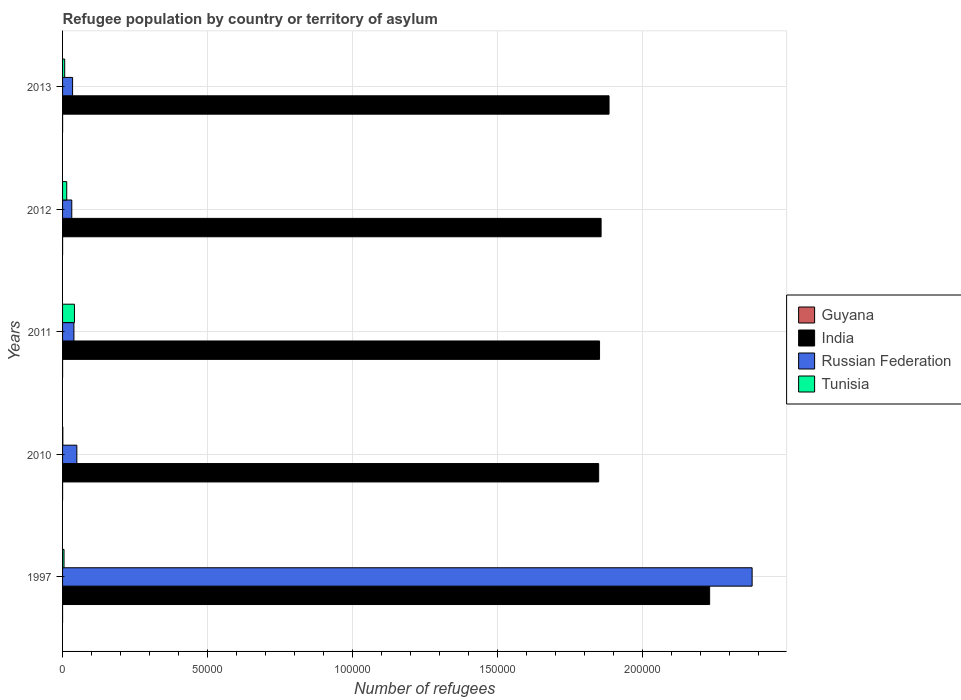How many groups of bars are there?
Your answer should be very brief. 5. Are the number of bars per tick equal to the number of legend labels?
Your answer should be compact. Yes. Are the number of bars on each tick of the Y-axis equal?
Provide a short and direct response. Yes. How many bars are there on the 2nd tick from the bottom?
Your response must be concise. 4. What is the number of refugees in Russian Federation in 2011?
Keep it short and to the point. 3914. Across all years, what is the maximum number of refugees in India?
Ensure brevity in your answer.  2.23e+05. In which year was the number of refugees in Tunisia minimum?
Offer a very short reply. 2010. What is the total number of refugees in Tunisia in the graph?
Offer a very short reply. 6857. What is the difference between the number of refugees in Tunisia in 1997 and that in 2011?
Your answer should be compact. -3591. What is the difference between the number of refugees in Russian Federation in 2013 and the number of refugees in Tunisia in 2012?
Provide a succinct answer. 2023. What is the average number of refugees in Tunisia per year?
Offer a terse response. 1371.4. In the year 2013, what is the difference between the number of refugees in Guyana and number of refugees in Russian Federation?
Give a very brief answer. -3447. In how many years, is the number of refugees in Russian Federation greater than 20000 ?
Your answer should be very brief. 1. What is the ratio of the number of refugees in Tunisia in 2010 to that in 2012?
Make the answer very short. 0.06. Is the number of refugees in Guyana in 2011 less than that in 2013?
Your answer should be compact. Yes. Is the difference between the number of refugees in Guyana in 1997 and 2013 greater than the difference between the number of refugees in Russian Federation in 1997 and 2013?
Make the answer very short. No. What is the difference between the highest and the second highest number of refugees in Tunisia?
Your answer should be very brief. 2662. What is the difference between the highest and the lowest number of refugees in India?
Offer a terse response. 3.83e+04. Is it the case that in every year, the sum of the number of refugees in Guyana and number of refugees in Tunisia is greater than the sum of number of refugees in India and number of refugees in Russian Federation?
Ensure brevity in your answer.  No. What does the 2nd bar from the top in 2011 represents?
Offer a terse response. Russian Federation. What does the 1st bar from the bottom in 1997 represents?
Provide a succinct answer. Guyana. How many years are there in the graph?
Make the answer very short. 5. What is the difference between two consecutive major ticks on the X-axis?
Offer a terse response. 5.00e+04. Are the values on the major ticks of X-axis written in scientific E-notation?
Offer a very short reply. No. How many legend labels are there?
Make the answer very short. 4. How are the legend labels stacked?
Your answer should be very brief. Vertical. What is the title of the graph?
Offer a very short reply. Refugee population by country or territory of asylum. What is the label or title of the X-axis?
Provide a short and direct response. Number of refugees. What is the Number of refugees in India in 1997?
Offer a terse response. 2.23e+05. What is the Number of refugees in Russian Federation in 1997?
Make the answer very short. 2.38e+05. What is the Number of refugees of Tunisia in 1997?
Provide a short and direct response. 506. What is the Number of refugees in Guyana in 2010?
Keep it short and to the point. 7. What is the Number of refugees in India in 2010?
Provide a succinct answer. 1.85e+05. What is the Number of refugees in Russian Federation in 2010?
Offer a very short reply. 4922. What is the Number of refugees of Tunisia in 2010?
Ensure brevity in your answer.  89. What is the Number of refugees in India in 2011?
Provide a short and direct response. 1.85e+05. What is the Number of refugees of Russian Federation in 2011?
Give a very brief answer. 3914. What is the Number of refugees in Tunisia in 2011?
Keep it short and to the point. 4097. What is the Number of refugees in India in 2012?
Give a very brief answer. 1.86e+05. What is the Number of refugees of Russian Federation in 2012?
Give a very brief answer. 3178. What is the Number of refugees in Tunisia in 2012?
Your response must be concise. 1435. What is the Number of refugees of India in 2013?
Offer a terse response. 1.88e+05. What is the Number of refugees in Russian Federation in 2013?
Ensure brevity in your answer.  3458. What is the Number of refugees of Tunisia in 2013?
Give a very brief answer. 730. Across all years, what is the maximum Number of refugees of Guyana?
Your answer should be compact. 11. Across all years, what is the maximum Number of refugees of India?
Offer a terse response. 2.23e+05. Across all years, what is the maximum Number of refugees of Russian Federation?
Provide a short and direct response. 2.38e+05. Across all years, what is the maximum Number of refugees of Tunisia?
Offer a very short reply. 4097. Across all years, what is the minimum Number of refugees of Guyana?
Give a very brief answer. 1. Across all years, what is the minimum Number of refugees of India?
Offer a terse response. 1.85e+05. Across all years, what is the minimum Number of refugees in Russian Federation?
Make the answer very short. 3178. Across all years, what is the minimum Number of refugees in Tunisia?
Provide a short and direct response. 89. What is the total Number of refugees of Guyana in the graph?
Offer a very short reply. 33. What is the total Number of refugees in India in the graph?
Keep it short and to the point. 9.67e+05. What is the total Number of refugees in Russian Federation in the graph?
Your answer should be very brief. 2.53e+05. What is the total Number of refugees in Tunisia in the graph?
Keep it short and to the point. 6857. What is the difference between the Number of refugees of India in 1997 and that in 2010?
Your answer should be compact. 3.83e+04. What is the difference between the Number of refugees of Russian Federation in 1997 and that in 2010?
Ensure brevity in your answer.  2.33e+05. What is the difference between the Number of refugees of Tunisia in 1997 and that in 2010?
Your answer should be compact. 417. What is the difference between the Number of refugees of India in 1997 and that in 2011?
Your answer should be compact. 3.80e+04. What is the difference between the Number of refugees in Russian Federation in 1997 and that in 2011?
Your answer should be compact. 2.34e+05. What is the difference between the Number of refugees of Tunisia in 1997 and that in 2011?
Provide a short and direct response. -3591. What is the difference between the Number of refugees of Guyana in 1997 and that in 2012?
Your answer should be very brief. -6. What is the difference between the Number of refugees of India in 1997 and that in 2012?
Your answer should be compact. 3.74e+04. What is the difference between the Number of refugees in Russian Federation in 1997 and that in 2012?
Your answer should be very brief. 2.35e+05. What is the difference between the Number of refugees in Tunisia in 1997 and that in 2012?
Provide a succinct answer. -929. What is the difference between the Number of refugees in Guyana in 1997 and that in 2013?
Offer a very short reply. -10. What is the difference between the Number of refugees of India in 1997 and that in 2013?
Your answer should be compact. 3.47e+04. What is the difference between the Number of refugees in Russian Federation in 1997 and that in 2013?
Your answer should be compact. 2.34e+05. What is the difference between the Number of refugees of Tunisia in 1997 and that in 2013?
Ensure brevity in your answer.  -224. What is the difference between the Number of refugees in India in 2010 and that in 2011?
Give a very brief answer. -297. What is the difference between the Number of refugees in Russian Federation in 2010 and that in 2011?
Ensure brevity in your answer.  1008. What is the difference between the Number of refugees in Tunisia in 2010 and that in 2011?
Offer a terse response. -4008. What is the difference between the Number of refugees in India in 2010 and that in 2012?
Give a very brief answer. -835. What is the difference between the Number of refugees in Russian Federation in 2010 and that in 2012?
Provide a short and direct response. 1744. What is the difference between the Number of refugees of Tunisia in 2010 and that in 2012?
Ensure brevity in your answer.  -1346. What is the difference between the Number of refugees in Guyana in 2010 and that in 2013?
Make the answer very short. -4. What is the difference between the Number of refugees of India in 2010 and that in 2013?
Offer a very short reply. -3574. What is the difference between the Number of refugees of Russian Federation in 2010 and that in 2013?
Keep it short and to the point. 1464. What is the difference between the Number of refugees of Tunisia in 2010 and that in 2013?
Provide a succinct answer. -641. What is the difference between the Number of refugees of Guyana in 2011 and that in 2012?
Provide a short and direct response. 0. What is the difference between the Number of refugees in India in 2011 and that in 2012?
Make the answer very short. -538. What is the difference between the Number of refugees of Russian Federation in 2011 and that in 2012?
Keep it short and to the point. 736. What is the difference between the Number of refugees in Tunisia in 2011 and that in 2012?
Keep it short and to the point. 2662. What is the difference between the Number of refugees of Guyana in 2011 and that in 2013?
Make the answer very short. -4. What is the difference between the Number of refugees of India in 2011 and that in 2013?
Ensure brevity in your answer.  -3277. What is the difference between the Number of refugees in Russian Federation in 2011 and that in 2013?
Provide a short and direct response. 456. What is the difference between the Number of refugees in Tunisia in 2011 and that in 2013?
Your answer should be very brief. 3367. What is the difference between the Number of refugees in India in 2012 and that in 2013?
Offer a very short reply. -2739. What is the difference between the Number of refugees of Russian Federation in 2012 and that in 2013?
Your answer should be very brief. -280. What is the difference between the Number of refugees in Tunisia in 2012 and that in 2013?
Ensure brevity in your answer.  705. What is the difference between the Number of refugees of Guyana in 1997 and the Number of refugees of India in 2010?
Keep it short and to the point. -1.85e+05. What is the difference between the Number of refugees of Guyana in 1997 and the Number of refugees of Russian Federation in 2010?
Keep it short and to the point. -4921. What is the difference between the Number of refugees of Guyana in 1997 and the Number of refugees of Tunisia in 2010?
Provide a short and direct response. -88. What is the difference between the Number of refugees in India in 1997 and the Number of refugees in Russian Federation in 2010?
Provide a succinct answer. 2.18e+05. What is the difference between the Number of refugees in India in 1997 and the Number of refugees in Tunisia in 2010?
Your answer should be very brief. 2.23e+05. What is the difference between the Number of refugees in Russian Federation in 1997 and the Number of refugees in Tunisia in 2010?
Your answer should be compact. 2.38e+05. What is the difference between the Number of refugees in Guyana in 1997 and the Number of refugees in India in 2011?
Give a very brief answer. -1.85e+05. What is the difference between the Number of refugees in Guyana in 1997 and the Number of refugees in Russian Federation in 2011?
Your answer should be compact. -3913. What is the difference between the Number of refugees of Guyana in 1997 and the Number of refugees of Tunisia in 2011?
Your answer should be very brief. -4096. What is the difference between the Number of refugees of India in 1997 and the Number of refugees of Russian Federation in 2011?
Ensure brevity in your answer.  2.19e+05. What is the difference between the Number of refugees in India in 1997 and the Number of refugees in Tunisia in 2011?
Offer a terse response. 2.19e+05. What is the difference between the Number of refugees in Russian Federation in 1997 and the Number of refugees in Tunisia in 2011?
Your answer should be very brief. 2.34e+05. What is the difference between the Number of refugees of Guyana in 1997 and the Number of refugees of India in 2012?
Your answer should be compact. -1.86e+05. What is the difference between the Number of refugees in Guyana in 1997 and the Number of refugees in Russian Federation in 2012?
Provide a short and direct response. -3177. What is the difference between the Number of refugees of Guyana in 1997 and the Number of refugees of Tunisia in 2012?
Offer a terse response. -1434. What is the difference between the Number of refugees in India in 1997 and the Number of refugees in Russian Federation in 2012?
Ensure brevity in your answer.  2.20e+05. What is the difference between the Number of refugees of India in 1997 and the Number of refugees of Tunisia in 2012?
Offer a terse response. 2.22e+05. What is the difference between the Number of refugees in Russian Federation in 1997 and the Number of refugees in Tunisia in 2012?
Ensure brevity in your answer.  2.36e+05. What is the difference between the Number of refugees of Guyana in 1997 and the Number of refugees of India in 2013?
Ensure brevity in your answer.  -1.88e+05. What is the difference between the Number of refugees of Guyana in 1997 and the Number of refugees of Russian Federation in 2013?
Offer a terse response. -3457. What is the difference between the Number of refugees of Guyana in 1997 and the Number of refugees of Tunisia in 2013?
Your answer should be compact. -729. What is the difference between the Number of refugees in India in 1997 and the Number of refugees in Russian Federation in 2013?
Ensure brevity in your answer.  2.20e+05. What is the difference between the Number of refugees of India in 1997 and the Number of refugees of Tunisia in 2013?
Give a very brief answer. 2.22e+05. What is the difference between the Number of refugees of Russian Federation in 1997 and the Number of refugees of Tunisia in 2013?
Give a very brief answer. 2.37e+05. What is the difference between the Number of refugees in Guyana in 2010 and the Number of refugees in India in 2011?
Make the answer very short. -1.85e+05. What is the difference between the Number of refugees in Guyana in 2010 and the Number of refugees in Russian Federation in 2011?
Provide a short and direct response. -3907. What is the difference between the Number of refugees of Guyana in 2010 and the Number of refugees of Tunisia in 2011?
Provide a succinct answer. -4090. What is the difference between the Number of refugees of India in 2010 and the Number of refugees of Russian Federation in 2011?
Your answer should be very brief. 1.81e+05. What is the difference between the Number of refugees in India in 2010 and the Number of refugees in Tunisia in 2011?
Provide a succinct answer. 1.81e+05. What is the difference between the Number of refugees of Russian Federation in 2010 and the Number of refugees of Tunisia in 2011?
Give a very brief answer. 825. What is the difference between the Number of refugees in Guyana in 2010 and the Number of refugees in India in 2012?
Keep it short and to the point. -1.86e+05. What is the difference between the Number of refugees in Guyana in 2010 and the Number of refugees in Russian Federation in 2012?
Give a very brief answer. -3171. What is the difference between the Number of refugees of Guyana in 2010 and the Number of refugees of Tunisia in 2012?
Your answer should be compact. -1428. What is the difference between the Number of refugees of India in 2010 and the Number of refugees of Russian Federation in 2012?
Ensure brevity in your answer.  1.82e+05. What is the difference between the Number of refugees in India in 2010 and the Number of refugees in Tunisia in 2012?
Provide a succinct answer. 1.83e+05. What is the difference between the Number of refugees of Russian Federation in 2010 and the Number of refugees of Tunisia in 2012?
Offer a terse response. 3487. What is the difference between the Number of refugees of Guyana in 2010 and the Number of refugees of India in 2013?
Offer a very short reply. -1.88e+05. What is the difference between the Number of refugees of Guyana in 2010 and the Number of refugees of Russian Federation in 2013?
Make the answer very short. -3451. What is the difference between the Number of refugees in Guyana in 2010 and the Number of refugees in Tunisia in 2013?
Offer a terse response. -723. What is the difference between the Number of refugees in India in 2010 and the Number of refugees in Russian Federation in 2013?
Give a very brief answer. 1.81e+05. What is the difference between the Number of refugees in India in 2010 and the Number of refugees in Tunisia in 2013?
Make the answer very short. 1.84e+05. What is the difference between the Number of refugees of Russian Federation in 2010 and the Number of refugees of Tunisia in 2013?
Keep it short and to the point. 4192. What is the difference between the Number of refugees of Guyana in 2011 and the Number of refugees of India in 2012?
Provide a short and direct response. -1.86e+05. What is the difference between the Number of refugees of Guyana in 2011 and the Number of refugees of Russian Federation in 2012?
Offer a very short reply. -3171. What is the difference between the Number of refugees of Guyana in 2011 and the Number of refugees of Tunisia in 2012?
Offer a terse response. -1428. What is the difference between the Number of refugees of India in 2011 and the Number of refugees of Russian Federation in 2012?
Provide a short and direct response. 1.82e+05. What is the difference between the Number of refugees of India in 2011 and the Number of refugees of Tunisia in 2012?
Your answer should be very brief. 1.84e+05. What is the difference between the Number of refugees of Russian Federation in 2011 and the Number of refugees of Tunisia in 2012?
Provide a succinct answer. 2479. What is the difference between the Number of refugees in Guyana in 2011 and the Number of refugees in India in 2013?
Ensure brevity in your answer.  -1.88e+05. What is the difference between the Number of refugees of Guyana in 2011 and the Number of refugees of Russian Federation in 2013?
Give a very brief answer. -3451. What is the difference between the Number of refugees in Guyana in 2011 and the Number of refugees in Tunisia in 2013?
Your response must be concise. -723. What is the difference between the Number of refugees in India in 2011 and the Number of refugees in Russian Federation in 2013?
Ensure brevity in your answer.  1.82e+05. What is the difference between the Number of refugees of India in 2011 and the Number of refugees of Tunisia in 2013?
Offer a terse response. 1.84e+05. What is the difference between the Number of refugees of Russian Federation in 2011 and the Number of refugees of Tunisia in 2013?
Keep it short and to the point. 3184. What is the difference between the Number of refugees in Guyana in 2012 and the Number of refugees in India in 2013?
Your answer should be compact. -1.88e+05. What is the difference between the Number of refugees of Guyana in 2012 and the Number of refugees of Russian Federation in 2013?
Your answer should be compact. -3451. What is the difference between the Number of refugees in Guyana in 2012 and the Number of refugees in Tunisia in 2013?
Your response must be concise. -723. What is the difference between the Number of refugees of India in 2012 and the Number of refugees of Russian Federation in 2013?
Your answer should be compact. 1.82e+05. What is the difference between the Number of refugees of India in 2012 and the Number of refugees of Tunisia in 2013?
Offer a very short reply. 1.85e+05. What is the difference between the Number of refugees in Russian Federation in 2012 and the Number of refugees in Tunisia in 2013?
Your answer should be compact. 2448. What is the average Number of refugees of India per year?
Your answer should be compact. 1.93e+05. What is the average Number of refugees in Russian Federation per year?
Provide a succinct answer. 5.06e+04. What is the average Number of refugees in Tunisia per year?
Keep it short and to the point. 1371.4. In the year 1997, what is the difference between the Number of refugees of Guyana and Number of refugees of India?
Your response must be concise. -2.23e+05. In the year 1997, what is the difference between the Number of refugees of Guyana and Number of refugees of Russian Federation?
Your response must be concise. -2.38e+05. In the year 1997, what is the difference between the Number of refugees in Guyana and Number of refugees in Tunisia?
Your answer should be compact. -505. In the year 1997, what is the difference between the Number of refugees in India and Number of refugees in Russian Federation?
Ensure brevity in your answer.  -1.46e+04. In the year 1997, what is the difference between the Number of refugees in India and Number of refugees in Tunisia?
Your response must be concise. 2.23e+05. In the year 1997, what is the difference between the Number of refugees of Russian Federation and Number of refugees of Tunisia?
Provide a short and direct response. 2.37e+05. In the year 2010, what is the difference between the Number of refugees of Guyana and Number of refugees of India?
Make the answer very short. -1.85e+05. In the year 2010, what is the difference between the Number of refugees of Guyana and Number of refugees of Russian Federation?
Provide a short and direct response. -4915. In the year 2010, what is the difference between the Number of refugees in Guyana and Number of refugees in Tunisia?
Keep it short and to the point. -82. In the year 2010, what is the difference between the Number of refugees in India and Number of refugees in Russian Federation?
Ensure brevity in your answer.  1.80e+05. In the year 2010, what is the difference between the Number of refugees of India and Number of refugees of Tunisia?
Keep it short and to the point. 1.85e+05. In the year 2010, what is the difference between the Number of refugees of Russian Federation and Number of refugees of Tunisia?
Offer a terse response. 4833. In the year 2011, what is the difference between the Number of refugees of Guyana and Number of refugees of India?
Give a very brief answer. -1.85e+05. In the year 2011, what is the difference between the Number of refugees in Guyana and Number of refugees in Russian Federation?
Keep it short and to the point. -3907. In the year 2011, what is the difference between the Number of refugees in Guyana and Number of refugees in Tunisia?
Provide a short and direct response. -4090. In the year 2011, what is the difference between the Number of refugees in India and Number of refugees in Russian Federation?
Ensure brevity in your answer.  1.81e+05. In the year 2011, what is the difference between the Number of refugees in India and Number of refugees in Tunisia?
Give a very brief answer. 1.81e+05. In the year 2011, what is the difference between the Number of refugees in Russian Federation and Number of refugees in Tunisia?
Your answer should be very brief. -183. In the year 2012, what is the difference between the Number of refugees of Guyana and Number of refugees of India?
Keep it short and to the point. -1.86e+05. In the year 2012, what is the difference between the Number of refugees of Guyana and Number of refugees of Russian Federation?
Offer a very short reply. -3171. In the year 2012, what is the difference between the Number of refugees in Guyana and Number of refugees in Tunisia?
Your answer should be very brief. -1428. In the year 2012, what is the difference between the Number of refugees in India and Number of refugees in Russian Federation?
Your answer should be compact. 1.82e+05. In the year 2012, what is the difference between the Number of refugees of India and Number of refugees of Tunisia?
Keep it short and to the point. 1.84e+05. In the year 2012, what is the difference between the Number of refugees in Russian Federation and Number of refugees in Tunisia?
Provide a short and direct response. 1743. In the year 2013, what is the difference between the Number of refugees of Guyana and Number of refugees of India?
Your answer should be compact. -1.88e+05. In the year 2013, what is the difference between the Number of refugees of Guyana and Number of refugees of Russian Federation?
Your answer should be compact. -3447. In the year 2013, what is the difference between the Number of refugees in Guyana and Number of refugees in Tunisia?
Make the answer very short. -719. In the year 2013, what is the difference between the Number of refugees in India and Number of refugees in Russian Federation?
Make the answer very short. 1.85e+05. In the year 2013, what is the difference between the Number of refugees of India and Number of refugees of Tunisia?
Offer a terse response. 1.88e+05. In the year 2013, what is the difference between the Number of refugees of Russian Federation and Number of refugees of Tunisia?
Offer a terse response. 2728. What is the ratio of the Number of refugees of Guyana in 1997 to that in 2010?
Your response must be concise. 0.14. What is the ratio of the Number of refugees in India in 1997 to that in 2010?
Your answer should be very brief. 1.21. What is the ratio of the Number of refugees in Russian Federation in 1997 to that in 2010?
Offer a very short reply. 48.3. What is the ratio of the Number of refugees of Tunisia in 1997 to that in 2010?
Your answer should be compact. 5.69. What is the ratio of the Number of refugees in Guyana in 1997 to that in 2011?
Your response must be concise. 0.14. What is the ratio of the Number of refugees in India in 1997 to that in 2011?
Offer a very short reply. 1.21. What is the ratio of the Number of refugees in Russian Federation in 1997 to that in 2011?
Offer a very short reply. 60.74. What is the ratio of the Number of refugees of Tunisia in 1997 to that in 2011?
Provide a succinct answer. 0.12. What is the ratio of the Number of refugees in Guyana in 1997 to that in 2012?
Offer a very short reply. 0.14. What is the ratio of the Number of refugees of India in 1997 to that in 2012?
Offer a very short reply. 1.2. What is the ratio of the Number of refugees of Russian Federation in 1997 to that in 2012?
Your answer should be very brief. 74.8. What is the ratio of the Number of refugees of Tunisia in 1997 to that in 2012?
Provide a succinct answer. 0.35. What is the ratio of the Number of refugees of Guyana in 1997 to that in 2013?
Your answer should be very brief. 0.09. What is the ratio of the Number of refugees of India in 1997 to that in 2013?
Offer a terse response. 1.18. What is the ratio of the Number of refugees in Russian Federation in 1997 to that in 2013?
Keep it short and to the point. 68.74. What is the ratio of the Number of refugees of Tunisia in 1997 to that in 2013?
Your answer should be very brief. 0.69. What is the ratio of the Number of refugees in Guyana in 2010 to that in 2011?
Ensure brevity in your answer.  1. What is the ratio of the Number of refugees in India in 2010 to that in 2011?
Keep it short and to the point. 1. What is the ratio of the Number of refugees of Russian Federation in 2010 to that in 2011?
Make the answer very short. 1.26. What is the ratio of the Number of refugees of Tunisia in 2010 to that in 2011?
Make the answer very short. 0.02. What is the ratio of the Number of refugees in India in 2010 to that in 2012?
Your answer should be compact. 1. What is the ratio of the Number of refugees in Russian Federation in 2010 to that in 2012?
Offer a terse response. 1.55. What is the ratio of the Number of refugees of Tunisia in 2010 to that in 2012?
Offer a terse response. 0.06. What is the ratio of the Number of refugees in Guyana in 2010 to that in 2013?
Your answer should be very brief. 0.64. What is the ratio of the Number of refugees of India in 2010 to that in 2013?
Give a very brief answer. 0.98. What is the ratio of the Number of refugees of Russian Federation in 2010 to that in 2013?
Provide a short and direct response. 1.42. What is the ratio of the Number of refugees of Tunisia in 2010 to that in 2013?
Your answer should be very brief. 0.12. What is the ratio of the Number of refugees of Russian Federation in 2011 to that in 2012?
Provide a short and direct response. 1.23. What is the ratio of the Number of refugees in Tunisia in 2011 to that in 2012?
Keep it short and to the point. 2.86. What is the ratio of the Number of refugees in Guyana in 2011 to that in 2013?
Make the answer very short. 0.64. What is the ratio of the Number of refugees of India in 2011 to that in 2013?
Make the answer very short. 0.98. What is the ratio of the Number of refugees in Russian Federation in 2011 to that in 2013?
Your answer should be compact. 1.13. What is the ratio of the Number of refugees in Tunisia in 2011 to that in 2013?
Your answer should be very brief. 5.61. What is the ratio of the Number of refugees in Guyana in 2012 to that in 2013?
Offer a terse response. 0.64. What is the ratio of the Number of refugees in India in 2012 to that in 2013?
Make the answer very short. 0.99. What is the ratio of the Number of refugees of Russian Federation in 2012 to that in 2013?
Ensure brevity in your answer.  0.92. What is the ratio of the Number of refugees of Tunisia in 2012 to that in 2013?
Your answer should be very brief. 1.97. What is the difference between the highest and the second highest Number of refugees in India?
Ensure brevity in your answer.  3.47e+04. What is the difference between the highest and the second highest Number of refugees of Russian Federation?
Provide a succinct answer. 2.33e+05. What is the difference between the highest and the second highest Number of refugees of Tunisia?
Keep it short and to the point. 2662. What is the difference between the highest and the lowest Number of refugees of Guyana?
Make the answer very short. 10. What is the difference between the highest and the lowest Number of refugees of India?
Keep it short and to the point. 3.83e+04. What is the difference between the highest and the lowest Number of refugees in Russian Federation?
Offer a very short reply. 2.35e+05. What is the difference between the highest and the lowest Number of refugees in Tunisia?
Provide a succinct answer. 4008. 